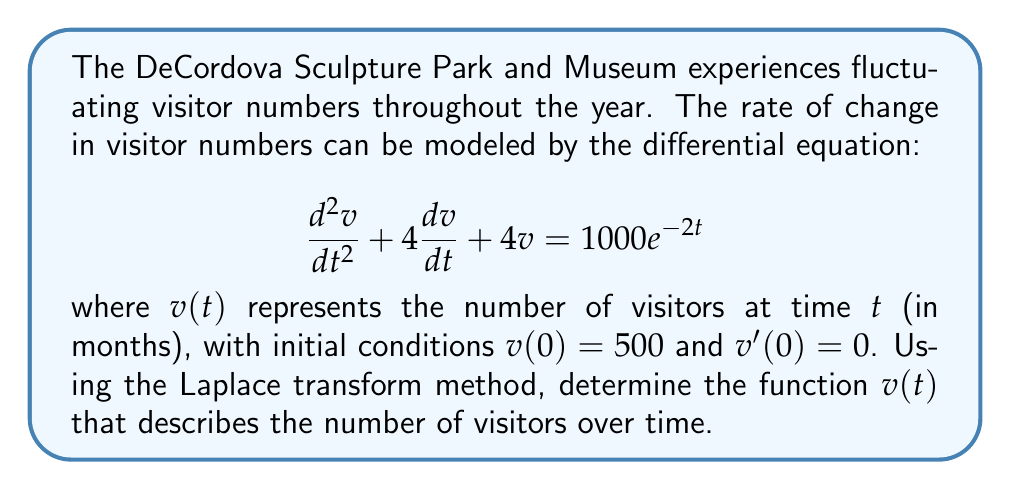Can you answer this question? Let's solve this problem step by step using the Laplace transform method:

1) First, we take the Laplace transform of both sides of the differential equation:

   $$\mathcal{L}\{v''(t) + 4v'(t) + 4v(t)\} = \mathcal{L}\{1000e^{-2t}\}$$

2) Using the properties of Laplace transforms:

   $$[s^2V(s) - sv(0) - v'(0)] + 4[sV(s) - v(0)] + 4V(s) = \frac{1000}{s+2}$$

3) Substituting the initial conditions $v(0) = 500$ and $v'(0) = 0$:

   $$s^2V(s) - 500s + 4sV(s) - 2000 + 4V(s) = \frac{1000}{s+2}$$

4) Simplify:

   $$(s^2 + 4s + 4)V(s) = \frac{1000}{s+2} + 500s + 2000$$

5) Factor out $V(s)$:

   $$V(s) = \frac{1000}{(s+2)(s^2 + 4s + 4)} + \frac{500s + 2000}{s^2 + 4s + 4}$$

6) The denominator $s^2 + 4s + 4$ can be factored as $(s+2)^2$. We can then use partial fraction decomposition:

   $$V(s) = \frac{A}{s+2} + \frac{B}{(s+2)^2} + \frac{Cs+D}{(s+2)^2}$$

7) Solving for the coefficients (details omitted for brevity):

   $$V(s) = \frac{250}{s+2} + \frac{250}{(s+2)^2} + \frac{500s+2000}{(s+2)^2}$$

8) Taking the inverse Laplace transform:

   $$v(t) = 250e^{-2t} + 250te^{-2t} + (500t+2000)e^{-2t}$$

9) Simplify:

   $$v(t) = (250 + 750t + 2000)e^{-2t}$$

This is the function that describes the number of visitors over time.
Answer: $v(t) = (250 + 750t + 2000)e^{-2t}$ 